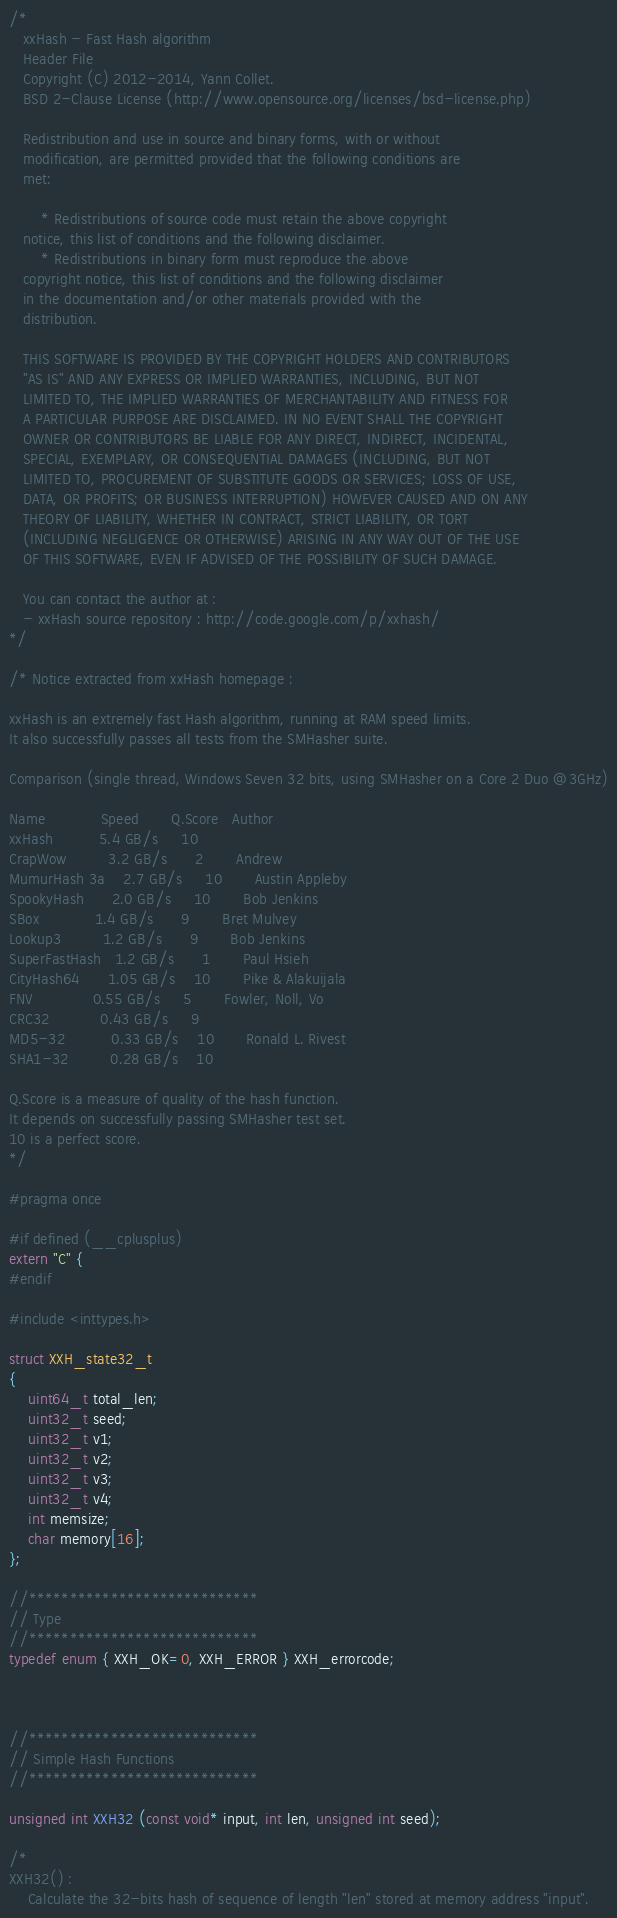Convert code to text. <code><loc_0><loc_0><loc_500><loc_500><_C_>/*
   xxHash - Fast Hash algorithm
   Header File
   Copyright (C) 2012-2014, Yann Collet.
   BSD 2-Clause License (http://www.opensource.org/licenses/bsd-license.php)

   Redistribution and use in source and binary forms, with or without
   modification, are permitted provided that the following conditions are
   met:
  
       * Redistributions of source code must retain the above copyright
   notice, this list of conditions and the following disclaimer.
       * Redistributions in binary form must reproduce the above
   copyright notice, this list of conditions and the following disclaimer
   in the documentation and/or other materials provided with the
   distribution.
  
   THIS SOFTWARE IS PROVIDED BY THE COPYRIGHT HOLDERS AND CONTRIBUTORS
   "AS IS" AND ANY EXPRESS OR IMPLIED WARRANTIES, INCLUDING, BUT NOT
   LIMITED TO, THE IMPLIED WARRANTIES OF MERCHANTABILITY AND FITNESS FOR
   A PARTICULAR PURPOSE ARE DISCLAIMED. IN NO EVENT SHALL THE COPYRIGHT
   OWNER OR CONTRIBUTORS BE LIABLE FOR ANY DIRECT, INDIRECT, INCIDENTAL,
   SPECIAL, EXEMPLARY, OR CONSEQUENTIAL DAMAGES (INCLUDING, BUT NOT
   LIMITED TO, PROCUREMENT OF SUBSTITUTE GOODS OR SERVICES; LOSS OF USE,
   DATA, OR PROFITS; OR BUSINESS INTERRUPTION) HOWEVER CAUSED AND ON ANY
   THEORY OF LIABILITY, WHETHER IN CONTRACT, STRICT LIABILITY, OR TORT
   (INCLUDING NEGLIGENCE OR OTHERWISE) ARISING IN ANY WAY OUT OF THE USE
   OF THIS SOFTWARE, EVEN IF ADVISED OF THE POSSIBILITY OF SUCH DAMAGE.

   You can contact the author at :
   - xxHash source repository : http://code.google.com/p/xxhash/
*/

/* Notice extracted from xxHash homepage :

xxHash is an extremely fast Hash algorithm, running at RAM speed limits.
It also successfully passes all tests from the SMHasher suite.

Comparison (single thread, Windows Seven 32 bits, using SMHasher on a Core 2 Duo @3GHz)

Name            Speed       Q.Score   Author
xxHash          5.4 GB/s     10
CrapWow         3.2 GB/s      2       Andrew
MumurHash 3a    2.7 GB/s     10       Austin Appleby
SpookyHash      2.0 GB/s     10       Bob Jenkins
SBox            1.4 GB/s      9       Bret Mulvey
Lookup3         1.2 GB/s      9       Bob Jenkins
SuperFastHash   1.2 GB/s      1       Paul Hsieh
CityHash64      1.05 GB/s    10       Pike & Alakuijala
FNV             0.55 GB/s     5       Fowler, Noll, Vo
CRC32           0.43 GB/s     9
MD5-32          0.33 GB/s    10       Ronald L. Rivest
SHA1-32         0.28 GB/s    10

Q.Score is a measure of quality of the hash function. 
It depends on successfully passing SMHasher test set. 
10 is a perfect score.
*/

#pragma once

#if defined (__cplusplus)
extern "C" {
#endif

#include <inttypes.h>

struct XXH_state32_t
{
    uint64_t total_len;
    uint32_t seed;
    uint32_t v1;
    uint32_t v2;
    uint32_t v3;
    uint32_t v4;
    int memsize;
    char memory[16];
};

//****************************
// Type
//****************************
typedef enum { XXH_OK=0, XXH_ERROR } XXH_errorcode;



//****************************
// Simple Hash Functions
//****************************

unsigned int XXH32 (const void* input, int len, unsigned int seed);

/*
XXH32() :
    Calculate the 32-bits hash of sequence of length "len" stored at memory address "input".</code> 